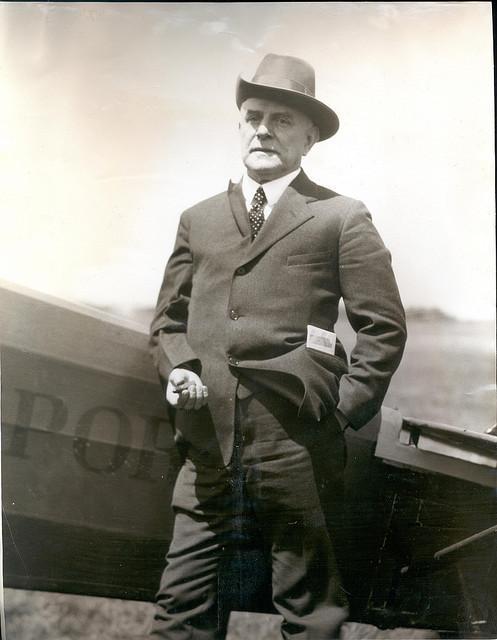How many hats are there?
Give a very brief answer. 1. How many train cars are under the poles?
Give a very brief answer. 0. 